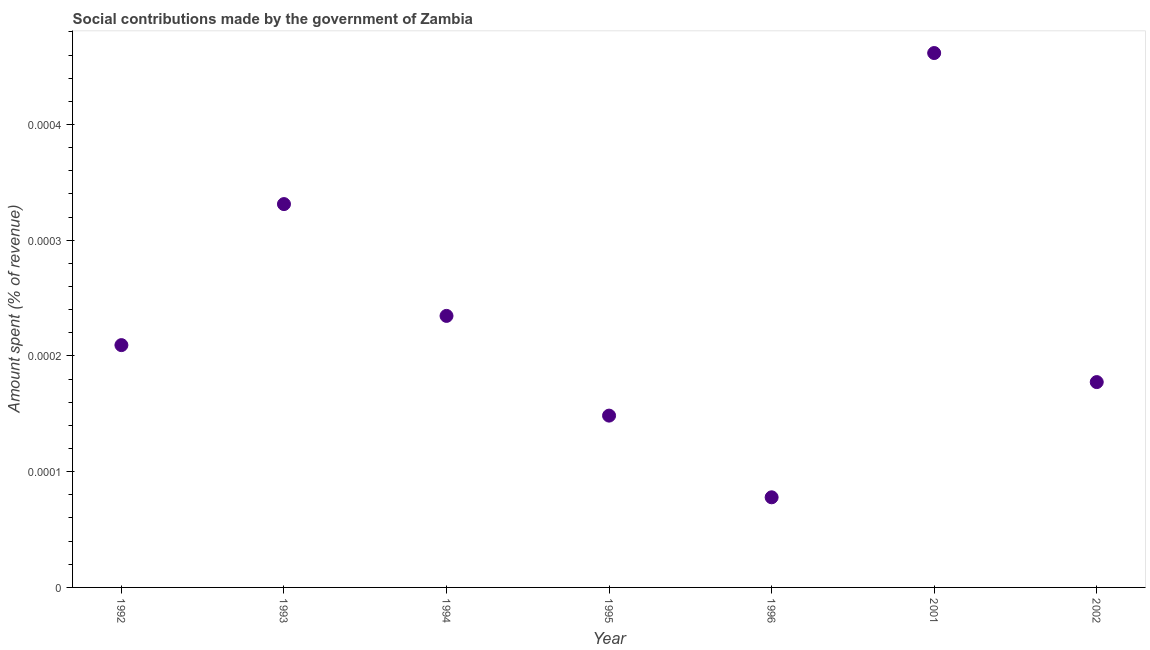What is the amount spent in making social contributions in 1996?
Make the answer very short. 7.78715120051914e-5. Across all years, what is the maximum amount spent in making social contributions?
Keep it short and to the point. 0. Across all years, what is the minimum amount spent in making social contributions?
Offer a terse response. 7.78715120051914e-5. In which year was the amount spent in making social contributions minimum?
Provide a short and direct response. 1996. What is the sum of the amount spent in making social contributions?
Provide a short and direct response. 0. What is the difference between the amount spent in making social contributions in 1992 and 1994?
Make the answer very short. -2.5245960949274004e-5. What is the average amount spent in making social contributions per year?
Provide a succinct answer. 0. What is the median amount spent in making social contributions?
Offer a terse response. 0. In how many years, is the amount spent in making social contributions greater than 0.00042 %?
Provide a succinct answer. 1. What is the ratio of the amount spent in making social contributions in 1996 to that in 2002?
Provide a short and direct response. 0.44. What is the difference between the highest and the second highest amount spent in making social contributions?
Provide a succinct answer. 0. Is the sum of the amount spent in making social contributions in 1992 and 1996 greater than the maximum amount spent in making social contributions across all years?
Provide a succinct answer. No. What is the difference between the highest and the lowest amount spent in making social contributions?
Make the answer very short. 0. Does the amount spent in making social contributions monotonically increase over the years?
Make the answer very short. No. What is the difference between two consecutive major ticks on the Y-axis?
Your answer should be compact. 0. Are the values on the major ticks of Y-axis written in scientific E-notation?
Make the answer very short. No. Does the graph contain grids?
Your answer should be compact. No. What is the title of the graph?
Your answer should be very brief. Social contributions made by the government of Zambia. What is the label or title of the X-axis?
Offer a terse response. Year. What is the label or title of the Y-axis?
Provide a succinct answer. Amount spent (% of revenue). What is the Amount spent (% of revenue) in 1992?
Provide a short and direct response. 0. What is the Amount spent (% of revenue) in 1993?
Offer a very short reply. 0. What is the Amount spent (% of revenue) in 1994?
Make the answer very short. 0. What is the Amount spent (% of revenue) in 1995?
Keep it short and to the point. 0. What is the Amount spent (% of revenue) in 1996?
Offer a very short reply. 7.78715120051914e-5. What is the Amount spent (% of revenue) in 2001?
Ensure brevity in your answer.  0. What is the Amount spent (% of revenue) in 2002?
Your response must be concise. 0. What is the difference between the Amount spent (% of revenue) in 1992 and 1993?
Your answer should be very brief. -0. What is the difference between the Amount spent (% of revenue) in 1992 and 1994?
Provide a succinct answer. -3e-5. What is the difference between the Amount spent (% of revenue) in 1992 and 1995?
Your answer should be very brief. 6e-5. What is the difference between the Amount spent (% of revenue) in 1992 and 1996?
Your response must be concise. 0. What is the difference between the Amount spent (% of revenue) in 1992 and 2001?
Your answer should be very brief. -0. What is the difference between the Amount spent (% of revenue) in 1992 and 2002?
Offer a very short reply. 3e-5. What is the difference between the Amount spent (% of revenue) in 1993 and 1994?
Make the answer very short. 0. What is the difference between the Amount spent (% of revenue) in 1993 and 1995?
Give a very brief answer. 0. What is the difference between the Amount spent (% of revenue) in 1993 and 1996?
Offer a very short reply. 0. What is the difference between the Amount spent (% of revenue) in 1993 and 2001?
Your answer should be compact. -0. What is the difference between the Amount spent (% of revenue) in 1993 and 2002?
Keep it short and to the point. 0. What is the difference between the Amount spent (% of revenue) in 1994 and 1995?
Your answer should be compact. 9e-5. What is the difference between the Amount spent (% of revenue) in 1994 and 1996?
Provide a succinct answer. 0. What is the difference between the Amount spent (% of revenue) in 1994 and 2001?
Your answer should be compact. -0. What is the difference between the Amount spent (% of revenue) in 1994 and 2002?
Your answer should be very brief. 6e-5. What is the difference between the Amount spent (% of revenue) in 1995 and 1996?
Your response must be concise. 7e-5. What is the difference between the Amount spent (% of revenue) in 1995 and 2001?
Keep it short and to the point. -0. What is the difference between the Amount spent (% of revenue) in 1995 and 2002?
Provide a succinct answer. -3e-5. What is the difference between the Amount spent (% of revenue) in 1996 and 2001?
Offer a very short reply. -0. What is the difference between the Amount spent (% of revenue) in 1996 and 2002?
Provide a short and direct response. -0. What is the difference between the Amount spent (% of revenue) in 2001 and 2002?
Give a very brief answer. 0. What is the ratio of the Amount spent (% of revenue) in 1992 to that in 1993?
Offer a terse response. 0.63. What is the ratio of the Amount spent (% of revenue) in 1992 to that in 1994?
Your answer should be compact. 0.89. What is the ratio of the Amount spent (% of revenue) in 1992 to that in 1995?
Keep it short and to the point. 1.41. What is the ratio of the Amount spent (% of revenue) in 1992 to that in 1996?
Make the answer very short. 2.69. What is the ratio of the Amount spent (% of revenue) in 1992 to that in 2001?
Give a very brief answer. 0.45. What is the ratio of the Amount spent (% of revenue) in 1992 to that in 2002?
Your answer should be very brief. 1.18. What is the ratio of the Amount spent (% of revenue) in 1993 to that in 1994?
Ensure brevity in your answer.  1.41. What is the ratio of the Amount spent (% of revenue) in 1993 to that in 1995?
Offer a very short reply. 2.23. What is the ratio of the Amount spent (% of revenue) in 1993 to that in 1996?
Keep it short and to the point. 4.25. What is the ratio of the Amount spent (% of revenue) in 1993 to that in 2001?
Ensure brevity in your answer.  0.72. What is the ratio of the Amount spent (% of revenue) in 1993 to that in 2002?
Provide a succinct answer. 1.87. What is the ratio of the Amount spent (% of revenue) in 1994 to that in 1995?
Offer a terse response. 1.58. What is the ratio of the Amount spent (% of revenue) in 1994 to that in 1996?
Provide a succinct answer. 3.01. What is the ratio of the Amount spent (% of revenue) in 1994 to that in 2001?
Your response must be concise. 0.51. What is the ratio of the Amount spent (% of revenue) in 1994 to that in 2002?
Provide a short and direct response. 1.32. What is the ratio of the Amount spent (% of revenue) in 1995 to that in 1996?
Offer a very short reply. 1.91. What is the ratio of the Amount spent (% of revenue) in 1995 to that in 2001?
Your answer should be compact. 0.32. What is the ratio of the Amount spent (% of revenue) in 1995 to that in 2002?
Your response must be concise. 0.84. What is the ratio of the Amount spent (% of revenue) in 1996 to that in 2001?
Keep it short and to the point. 0.17. What is the ratio of the Amount spent (% of revenue) in 1996 to that in 2002?
Your response must be concise. 0.44. What is the ratio of the Amount spent (% of revenue) in 2001 to that in 2002?
Your answer should be very brief. 2.6. 